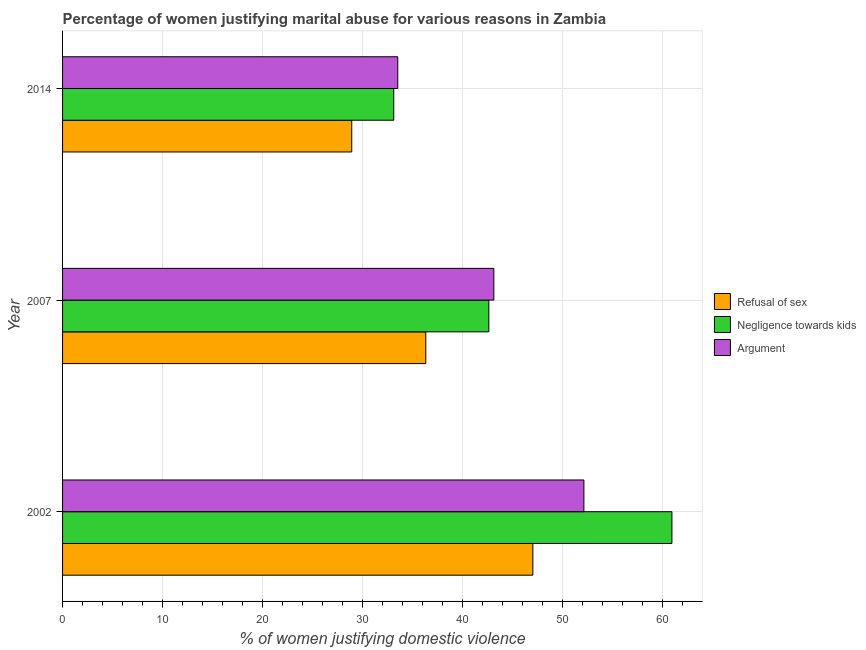Are the number of bars per tick equal to the number of legend labels?
Make the answer very short. Yes. How many bars are there on the 1st tick from the bottom?
Give a very brief answer. 3. What is the label of the 1st group of bars from the top?
Ensure brevity in your answer.  2014. What is the percentage of women justifying domestic violence due to negligence towards kids in 2007?
Offer a terse response. 42.6. Across all years, what is the maximum percentage of women justifying domestic violence due to negligence towards kids?
Keep it short and to the point. 60.9. Across all years, what is the minimum percentage of women justifying domestic violence due to refusal of sex?
Offer a terse response. 28.9. In which year was the percentage of women justifying domestic violence due to arguments maximum?
Ensure brevity in your answer.  2002. What is the total percentage of women justifying domestic violence due to negligence towards kids in the graph?
Ensure brevity in your answer.  136.6. What is the difference between the percentage of women justifying domestic violence due to negligence towards kids in 2002 and that in 2014?
Provide a short and direct response. 27.8. What is the difference between the percentage of women justifying domestic violence due to refusal of sex in 2007 and the percentage of women justifying domestic violence due to arguments in 2014?
Keep it short and to the point. 2.8. What is the average percentage of women justifying domestic violence due to arguments per year?
Your response must be concise. 42.9. In the year 2002, what is the difference between the percentage of women justifying domestic violence due to arguments and percentage of women justifying domestic violence due to negligence towards kids?
Ensure brevity in your answer.  -8.8. In how many years, is the percentage of women justifying domestic violence due to arguments greater than 38 %?
Your response must be concise. 2. What is the ratio of the percentage of women justifying domestic violence due to arguments in 2007 to that in 2014?
Offer a terse response. 1.29. Is the difference between the percentage of women justifying domestic violence due to refusal of sex in 2007 and 2014 greater than the difference between the percentage of women justifying domestic violence due to arguments in 2007 and 2014?
Your answer should be compact. No. What does the 3rd bar from the top in 2002 represents?
Offer a very short reply. Refusal of sex. What does the 3rd bar from the bottom in 2007 represents?
Give a very brief answer. Argument. How many bars are there?
Ensure brevity in your answer.  9. Are all the bars in the graph horizontal?
Provide a short and direct response. Yes. What is the difference between two consecutive major ticks on the X-axis?
Give a very brief answer. 10. Are the values on the major ticks of X-axis written in scientific E-notation?
Your response must be concise. No. Does the graph contain any zero values?
Make the answer very short. No. Does the graph contain grids?
Give a very brief answer. Yes. What is the title of the graph?
Keep it short and to the point. Percentage of women justifying marital abuse for various reasons in Zambia. Does "Coal" appear as one of the legend labels in the graph?
Give a very brief answer. No. What is the label or title of the X-axis?
Your answer should be compact. % of women justifying domestic violence. What is the % of women justifying domestic violence of Negligence towards kids in 2002?
Your response must be concise. 60.9. What is the % of women justifying domestic violence in Argument in 2002?
Provide a succinct answer. 52.1. What is the % of women justifying domestic violence in Refusal of sex in 2007?
Your answer should be very brief. 36.3. What is the % of women justifying domestic violence of Negligence towards kids in 2007?
Provide a short and direct response. 42.6. What is the % of women justifying domestic violence of Argument in 2007?
Offer a very short reply. 43.1. What is the % of women justifying domestic violence in Refusal of sex in 2014?
Make the answer very short. 28.9. What is the % of women justifying domestic violence in Negligence towards kids in 2014?
Provide a succinct answer. 33.1. What is the % of women justifying domestic violence in Argument in 2014?
Your answer should be compact. 33.5. Across all years, what is the maximum % of women justifying domestic violence in Negligence towards kids?
Make the answer very short. 60.9. Across all years, what is the maximum % of women justifying domestic violence of Argument?
Provide a short and direct response. 52.1. Across all years, what is the minimum % of women justifying domestic violence in Refusal of sex?
Your answer should be very brief. 28.9. Across all years, what is the minimum % of women justifying domestic violence in Negligence towards kids?
Offer a terse response. 33.1. Across all years, what is the minimum % of women justifying domestic violence of Argument?
Offer a terse response. 33.5. What is the total % of women justifying domestic violence in Refusal of sex in the graph?
Offer a very short reply. 112.2. What is the total % of women justifying domestic violence of Negligence towards kids in the graph?
Provide a succinct answer. 136.6. What is the total % of women justifying domestic violence in Argument in the graph?
Make the answer very short. 128.7. What is the difference between the % of women justifying domestic violence of Negligence towards kids in 2002 and that in 2007?
Give a very brief answer. 18.3. What is the difference between the % of women justifying domestic violence of Negligence towards kids in 2002 and that in 2014?
Offer a very short reply. 27.8. What is the difference between the % of women justifying domestic violence in Argument in 2002 and that in 2014?
Provide a succinct answer. 18.6. What is the difference between the % of women justifying domestic violence of Negligence towards kids in 2007 and that in 2014?
Give a very brief answer. 9.5. What is the difference between the % of women justifying domestic violence of Argument in 2007 and that in 2014?
Make the answer very short. 9.6. What is the difference between the % of women justifying domestic violence in Refusal of sex in 2002 and the % of women justifying domestic violence in Negligence towards kids in 2007?
Offer a very short reply. 4.4. What is the difference between the % of women justifying domestic violence in Refusal of sex in 2002 and the % of women justifying domestic violence in Negligence towards kids in 2014?
Your answer should be very brief. 13.9. What is the difference between the % of women justifying domestic violence of Negligence towards kids in 2002 and the % of women justifying domestic violence of Argument in 2014?
Your answer should be compact. 27.4. What is the difference between the % of women justifying domestic violence in Refusal of sex in 2007 and the % of women justifying domestic violence in Argument in 2014?
Keep it short and to the point. 2.8. What is the average % of women justifying domestic violence of Refusal of sex per year?
Offer a terse response. 37.4. What is the average % of women justifying domestic violence of Negligence towards kids per year?
Make the answer very short. 45.53. What is the average % of women justifying domestic violence in Argument per year?
Offer a very short reply. 42.9. In the year 2007, what is the difference between the % of women justifying domestic violence of Negligence towards kids and % of women justifying domestic violence of Argument?
Your answer should be very brief. -0.5. In the year 2014, what is the difference between the % of women justifying domestic violence of Refusal of sex and % of women justifying domestic violence of Argument?
Offer a very short reply. -4.6. What is the ratio of the % of women justifying domestic violence of Refusal of sex in 2002 to that in 2007?
Offer a very short reply. 1.29. What is the ratio of the % of women justifying domestic violence of Negligence towards kids in 2002 to that in 2007?
Your answer should be very brief. 1.43. What is the ratio of the % of women justifying domestic violence in Argument in 2002 to that in 2007?
Make the answer very short. 1.21. What is the ratio of the % of women justifying domestic violence of Refusal of sex in 2002 to that in 2014?
Your answer should be compact. 1.63. What is the ratio of the % of women justifying domestic violence of Negligence towards kids in 2002 to that in 2014?
Make the answer very short. 1.84. What is the ratio of the % of women justifying domestic violence in Argument in 2002 to that in 2014?
Offer a terse response. 1.56. What is the ratio of the % of women justifying domestic violence in Refusal of sex in 2007 to that in 2014?
Give a very brief answer. 1.26. What is the ratio of the % of women justifying domestic violence in Negligence towards kids in 2007 to that in 2014?
Your answer should be very brief. 1.29. What is the ratio of the % of women justifying domestic violence of Argument in 2007 to that in 2014?
Ensure brevity in your answer.  1.29. What is the difference between the highest and the second highest % of women justifying domestic violence in Refusal of sex?
Your answer should be very brief. 10.7. What is the difference between the highest and the second highest % of women justifying domestic violence in Argument?
Offer a terse response. 9. What is the difference between the highest and the lowest % of women justifying domestic violence in Negligence towards kids?
Give a very brief answer. 27.8. What is the difference between the highest and the lowest % of women justifying domestic violence in Argument?
Your answer should be compact. 18.6. 